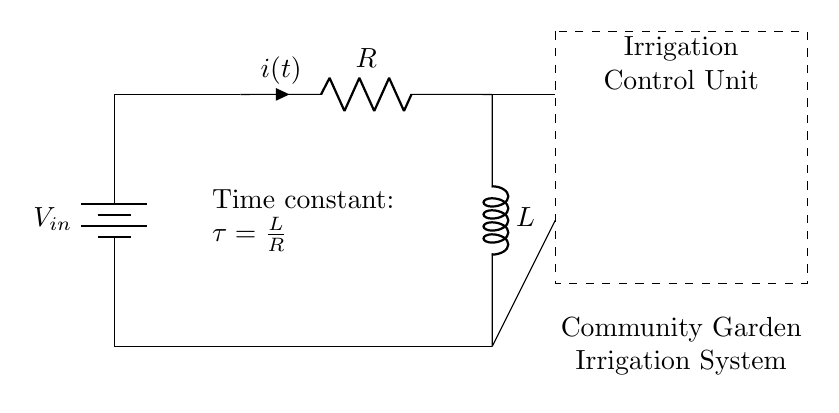What is the input voltage for this circuit? The input voltage is indicated as V_in, which represents the voltage supplied to the circuit.
Answer: V_in What are the components in this circuit? The components in this circuit include a resistor (R) and an inductor (L), connected between a battery and an irrigation control unit.
Answer: Resistor and inductor What is the time constant of this circuit? The time constant is defined as tau, which is given by the formula tau = L/R, indicating the relationship between the inductor and resistor in the circuit.
Answer: L/R How does the current flow in this circuit? The current flows from the positive terminal of the battery through the resistor and into the inductor, completing the circuit back to the battery's negative terminal.
Answer: From battery to resistor to inductor What role does the irrigation control unit play in this circuit? The irrigation control unit processes the current and activates the irrigation system based on the circuit's time delay characteristics, ensuring that water is delivered to the community garden effectively.
Answer: Controls irrigation timing What happens when the time constant increases? When the time constant, tau = L/R, increases (due to higher inductance or lower resistance), the circuit's response time to changes in voltage decreases, resulting in a longer delay before the irrigation system activates.
Answer: Response time increases What type of circuit is this? This is a resistor-inductor circuit, which is typically used in applications involving timing and control, such as automated irrigation systems.
Answer: Resistor-inductor circuit 